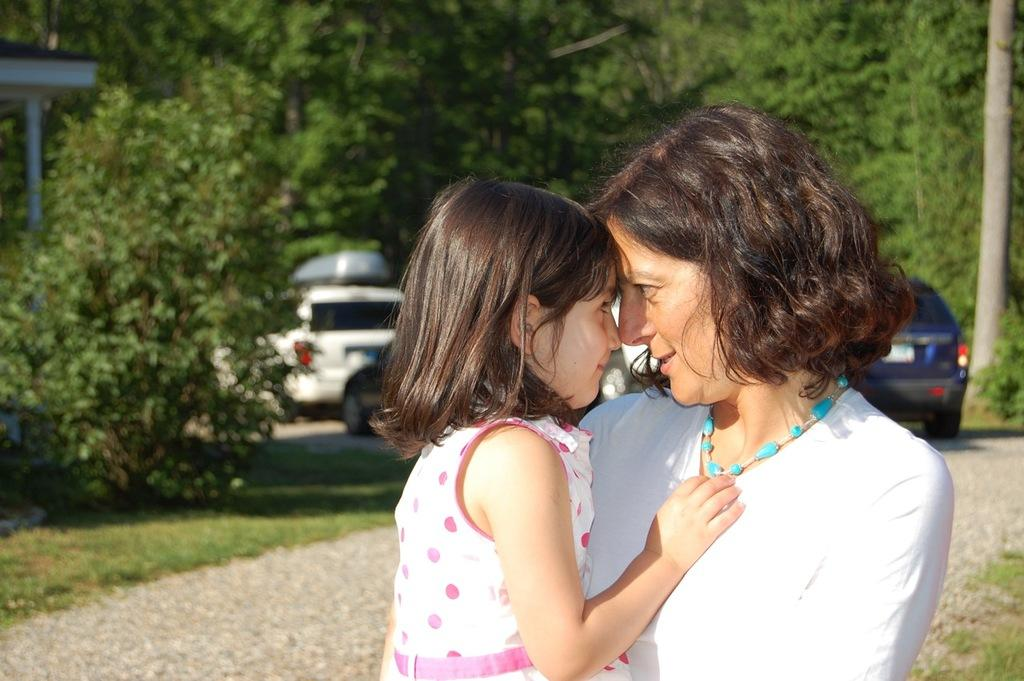What is happening in the center of the image? There is a lady holding a kid in the center of the image. What can be seen in the background of the image? There are vehicles on the road and trees visible in the background. Is there any structure in the background? Yes, there is a shed in the background. What color of paint is being used by the lady in the image? There is no indication of paint or painting in the image; the lady is holding a kid. 